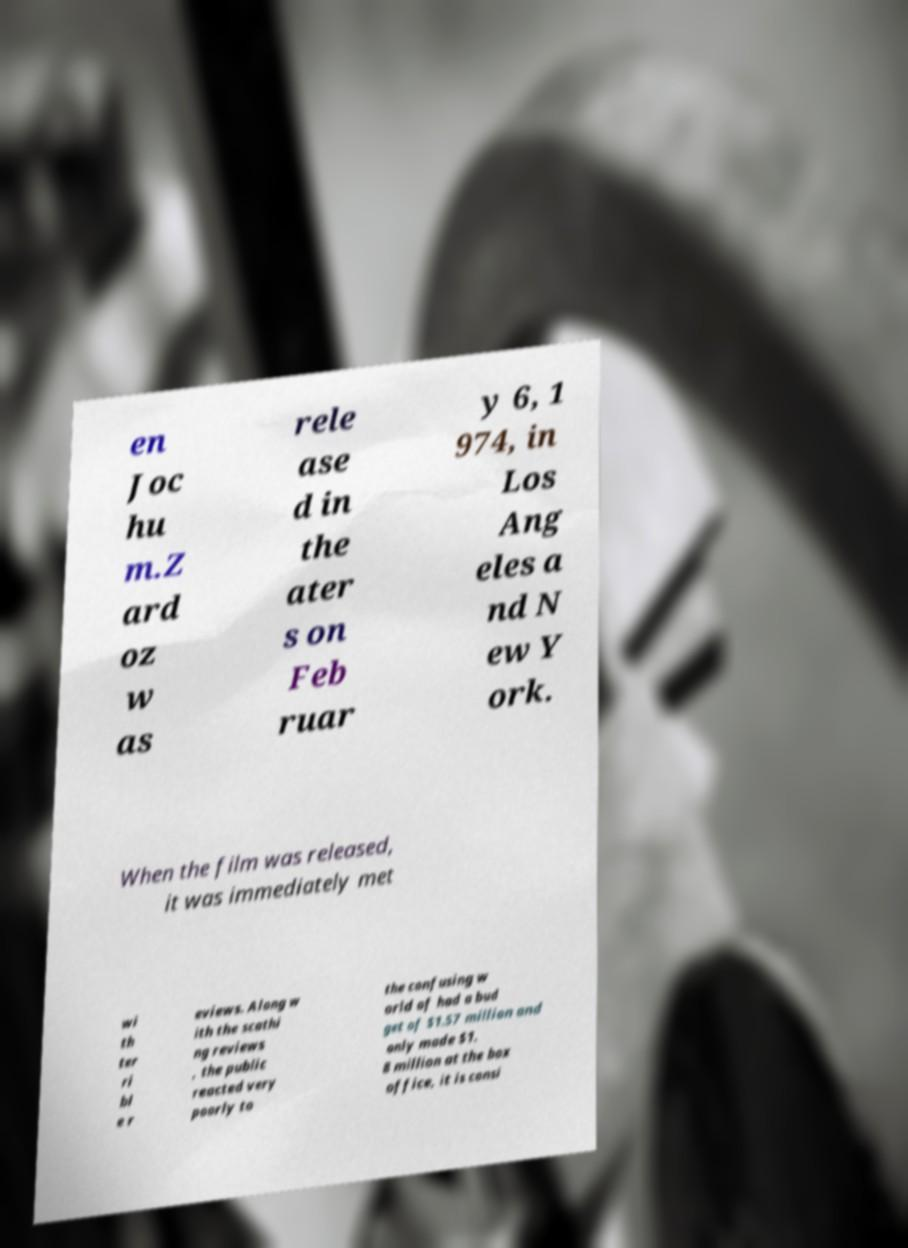There's text embedded in this image that I need extracted. Can you transcribe it verbatim? en Joc hu m.Z ard oz w as rele ase d in the ater s on Feb ruar y 6, 1 974, in Los Ang eles a nd N ew Y ork. When the film was released, it was immediately met wi th ter ri bl e r eviews. Along w ith the scathi ng reviews , the public reacted very poorly to the confusing w orld of had a bud get of $1.57 million and only made $1. 8 million at the box office, it is consi 